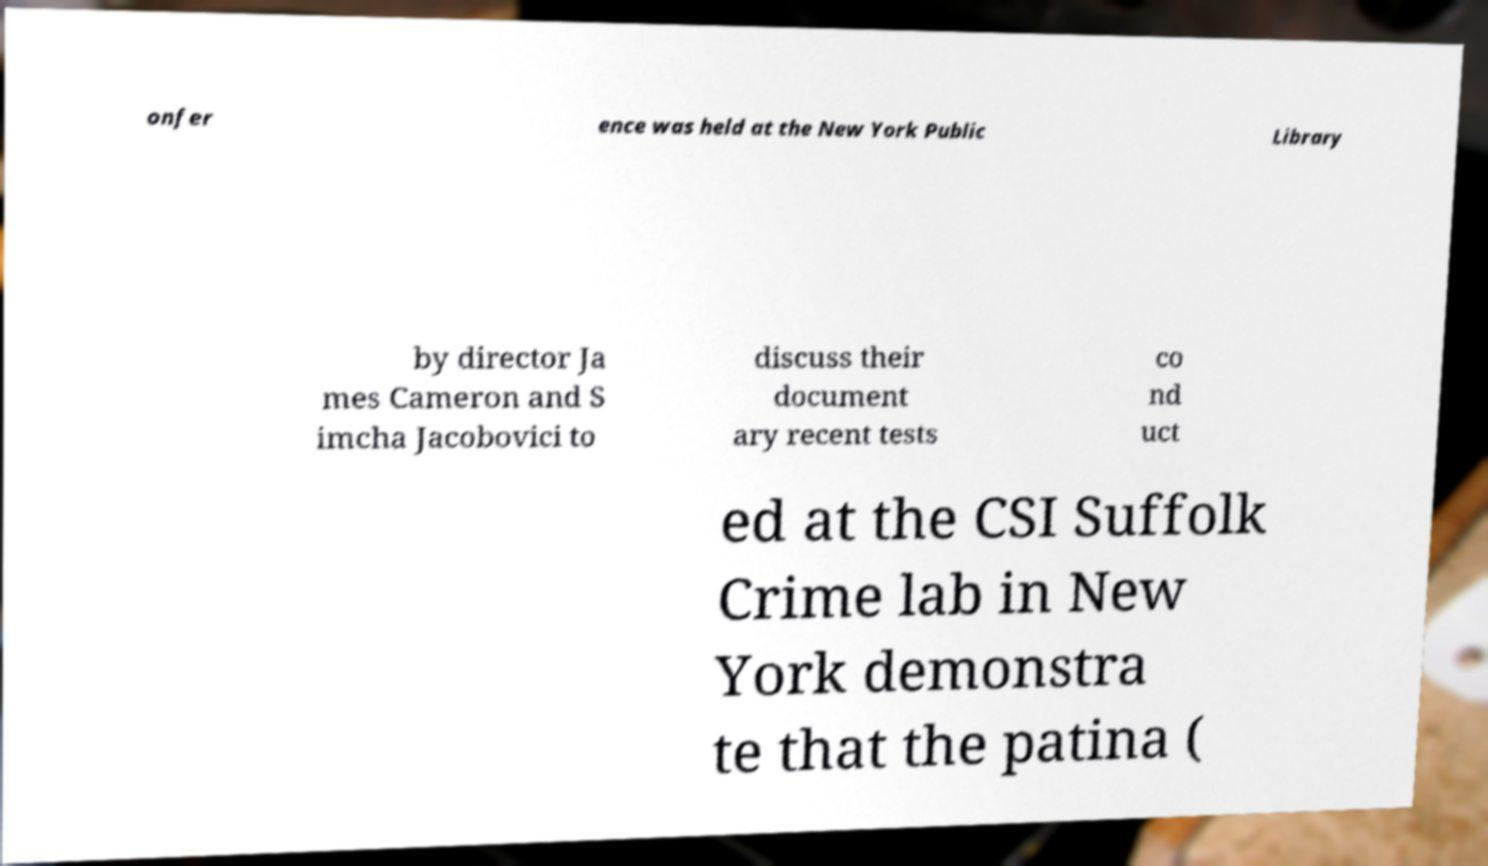There's text embedded in this image that I need extracted. Can you transcribe it verbatim? onfer ence was held at the New York Public Library by director Ja mes Cameron and S imcha Jacobovici to discuss their document ary recent tests co nd uct ed at the CSI Suffolk Crime lab in New York demonstra te that the patina ( 